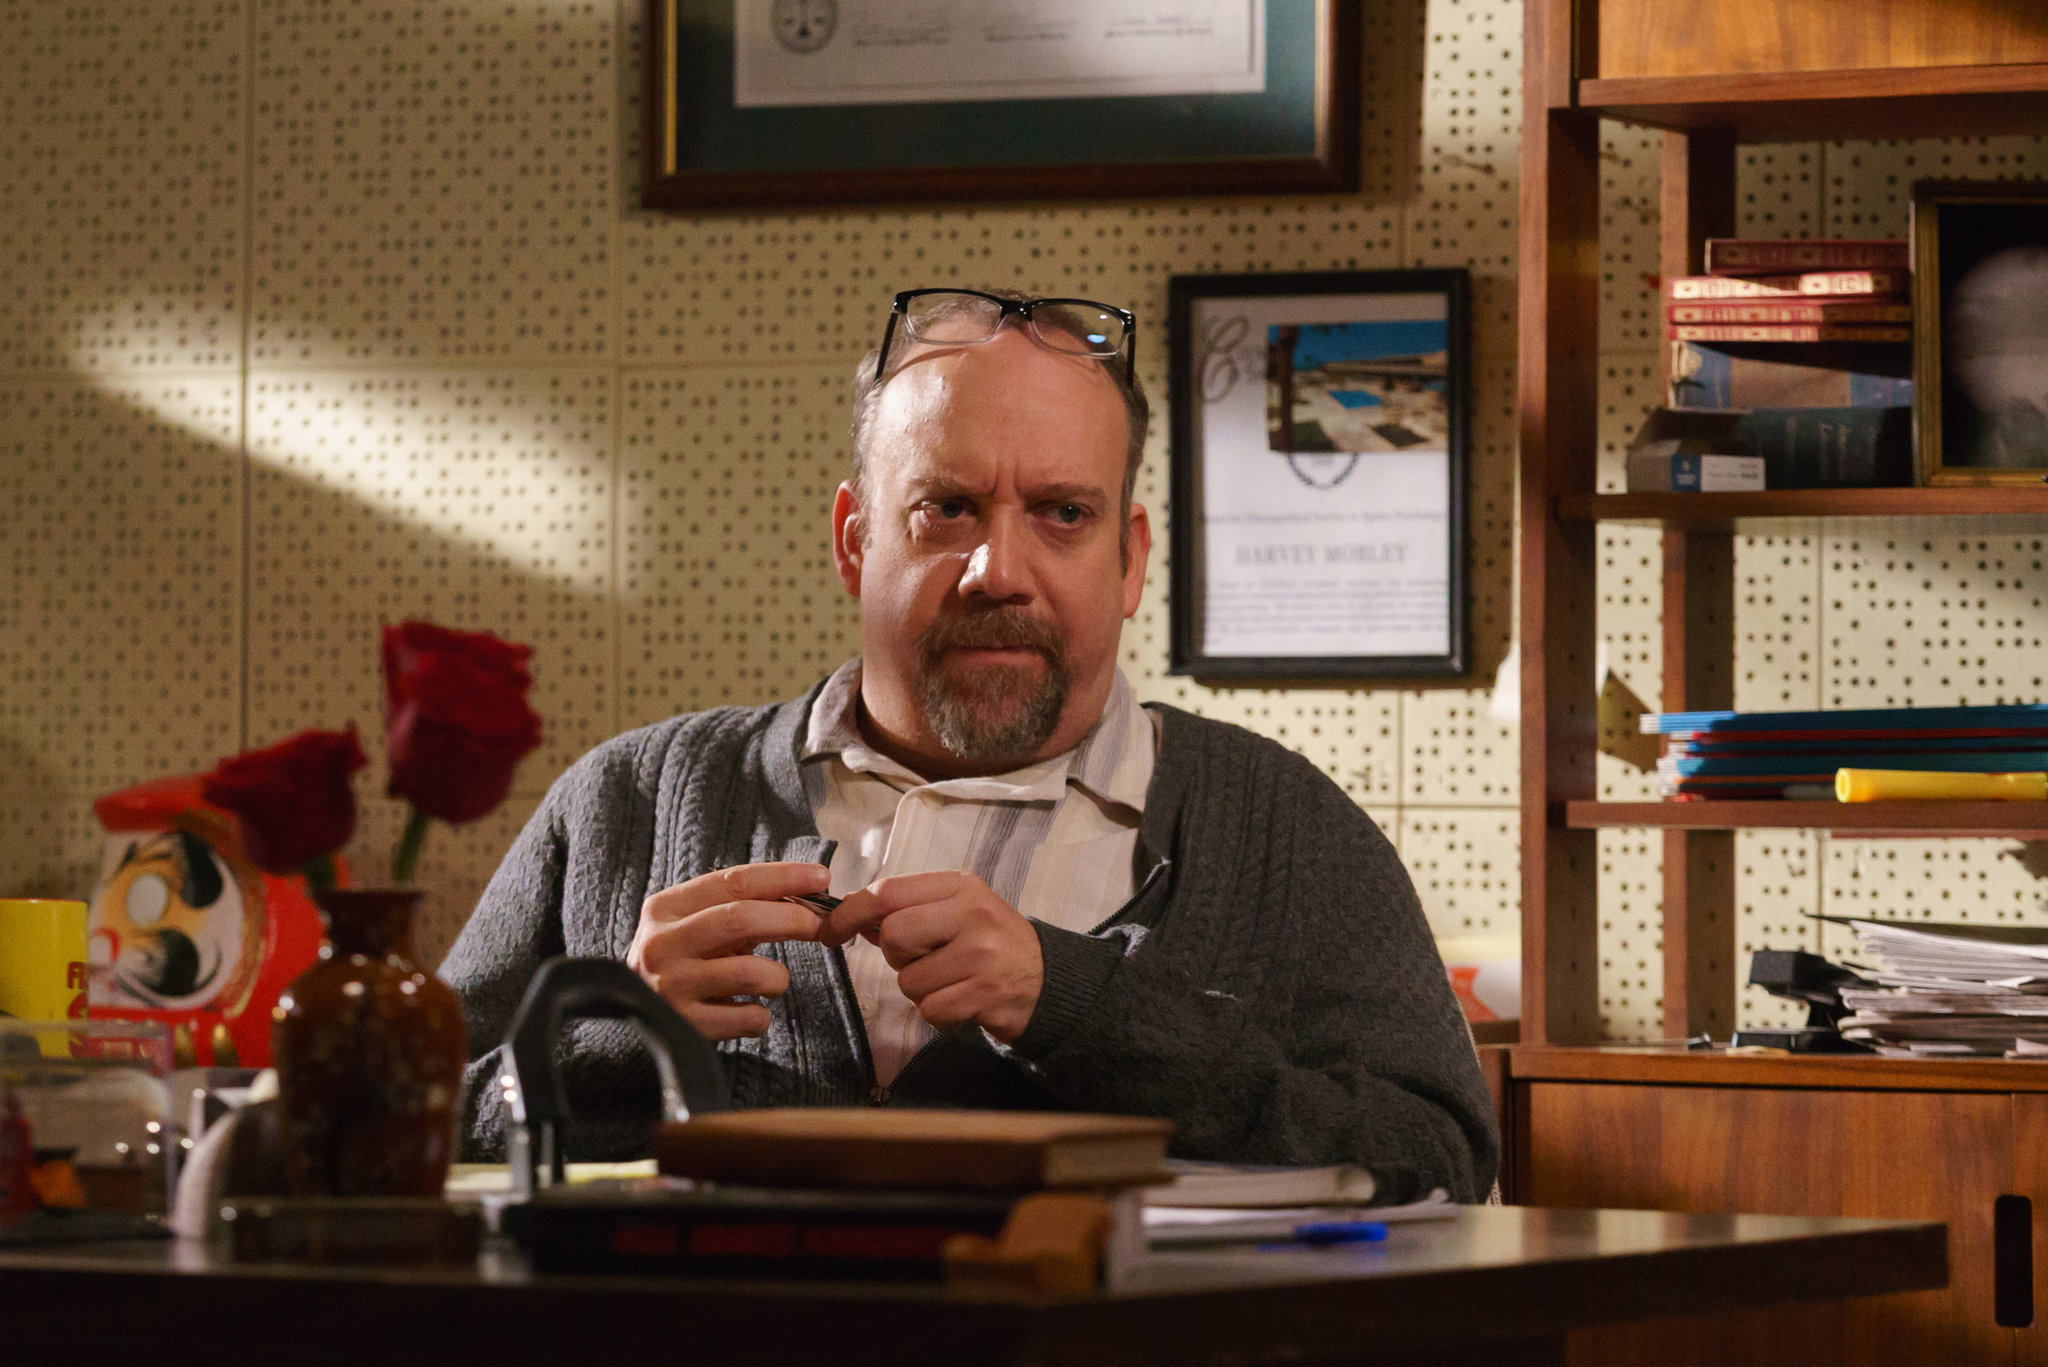Describe the atmosphere of the room and how it complements the man's demeanor. The room’s atmosphere is one of seriousness and intense focus, perfectly mirroring the man's demeanor. The warm hues of brown and orange create a cozy yet concentrated environment, which likely serves to enhance his deep thought processes. The cluttered desk, filled with papers, books, and personal items such as a coffee mug, speaks to a hardworking individual amidst a sea of ideas and projects. The framed pictures and full bookshelf in the background not only add character to the space but also highlight a life steeped in knowledge and study. 